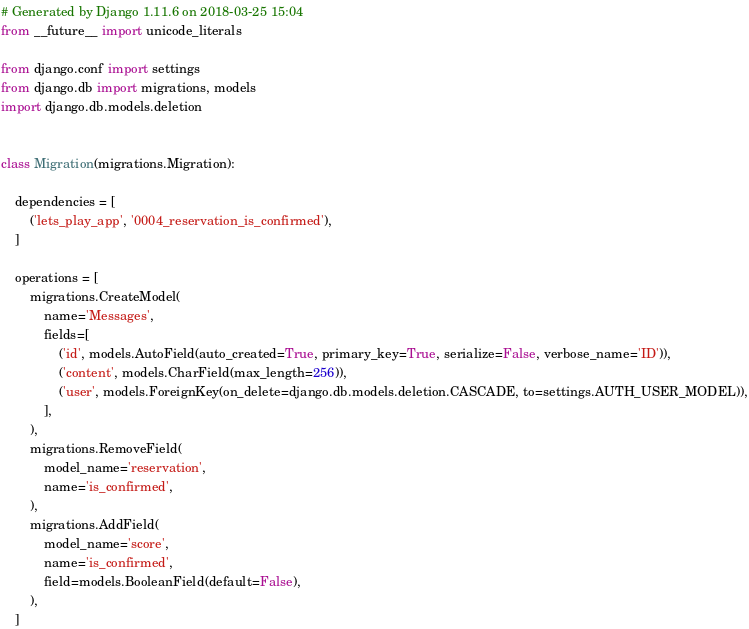Convert code to text. <code><loc_0><loc_0><loc_500><loc_500><_Python_># Generated by Django 1.11.6 on 2018-03-25 15:04
from __future__ import unicode_literals

from django.conf import settings
from django.db import migrations, models
import django.db.models.deletion


class Migration(migrations.Migration):

    dependencies = [
        ('lets_play_app', '0004_reservation_is_confirmed'),
    ]

    operations = [
        migrations.CreateModel(
            name='Messages',
            fields=[
                ('id', models.AutoField(auto_created=True, primary_key=True, serialize=False, verbose_name='ID')),
                ('content', models.CharField(max_length=256)),
                ('user', models.ForeignKey(on_delete=django.db.models.deletion.CASCADE, to=settings.AUTH_USER_MODEL)),
            ],
        ),
        migrations.RemoveField(
            model_name='reservation',
            name='is_confirmed',
        ),
        migrations.AddField(
            model_name='score',
            name='is_confirmed',
            field=models.BooleanField(default=False),
        ),
    ]
</code> 